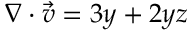Convert formula to latex. <formula><loc_0><loc_0><loc_500><loc_500>\nabla \cdot { \vec { v } } = 3 y + 2 y z</formula> 